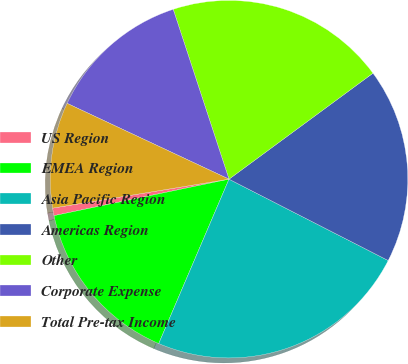<chart> <loc_0><loc_0><loc_500><loc_500><pie_chart><fcel>US Region<fcel>EMEA Region<fcel>Asia Pacific Region<fcel>Americas Region<fcel>Other<fcel>Corporate Expense<fcel>Total Pre-tax Income<nl><fcel>0.68%<fcel>15.3%<fcel>23.91%<fcel>17.62%<fcel>19.95%<fcel>12.98%<fcel>9.56%<nl></chart> 